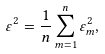<formula> <loc_0><loc_0><loc_500><loc_500>\varepsilon ^ { 2 } = \frac { 1 } { n } \sum _ { m = 1 } ^ { n } \varepsilon _ { m } ^ { 2 } ,</formula> 